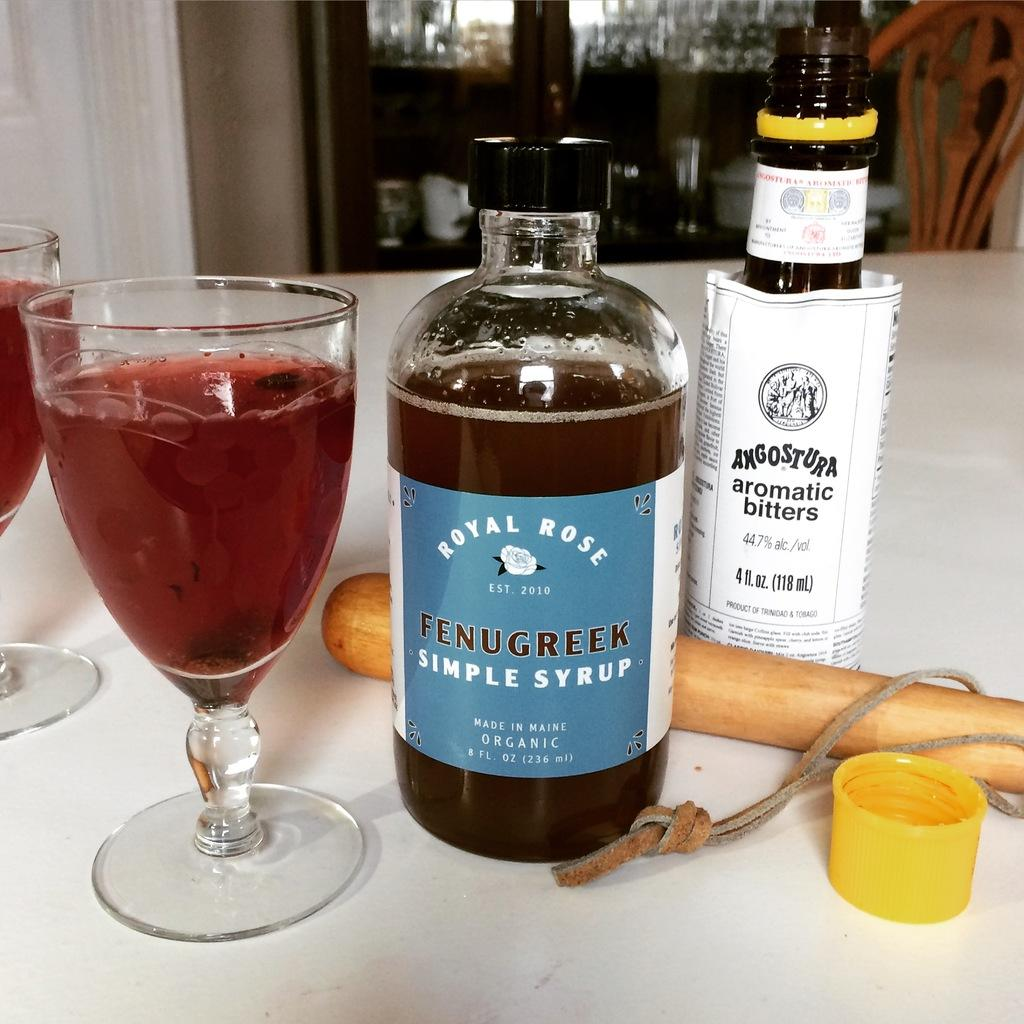<image>
Write a terse but informative summary of the picture. A bottle of simple syrup sits next to two drink glasses. 